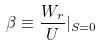<formula> <loc_0><loc_0><loc_500><loc_500>\beta \equiv \frac { W _ { r } } { U } | _ { S = 0 }</formula> 